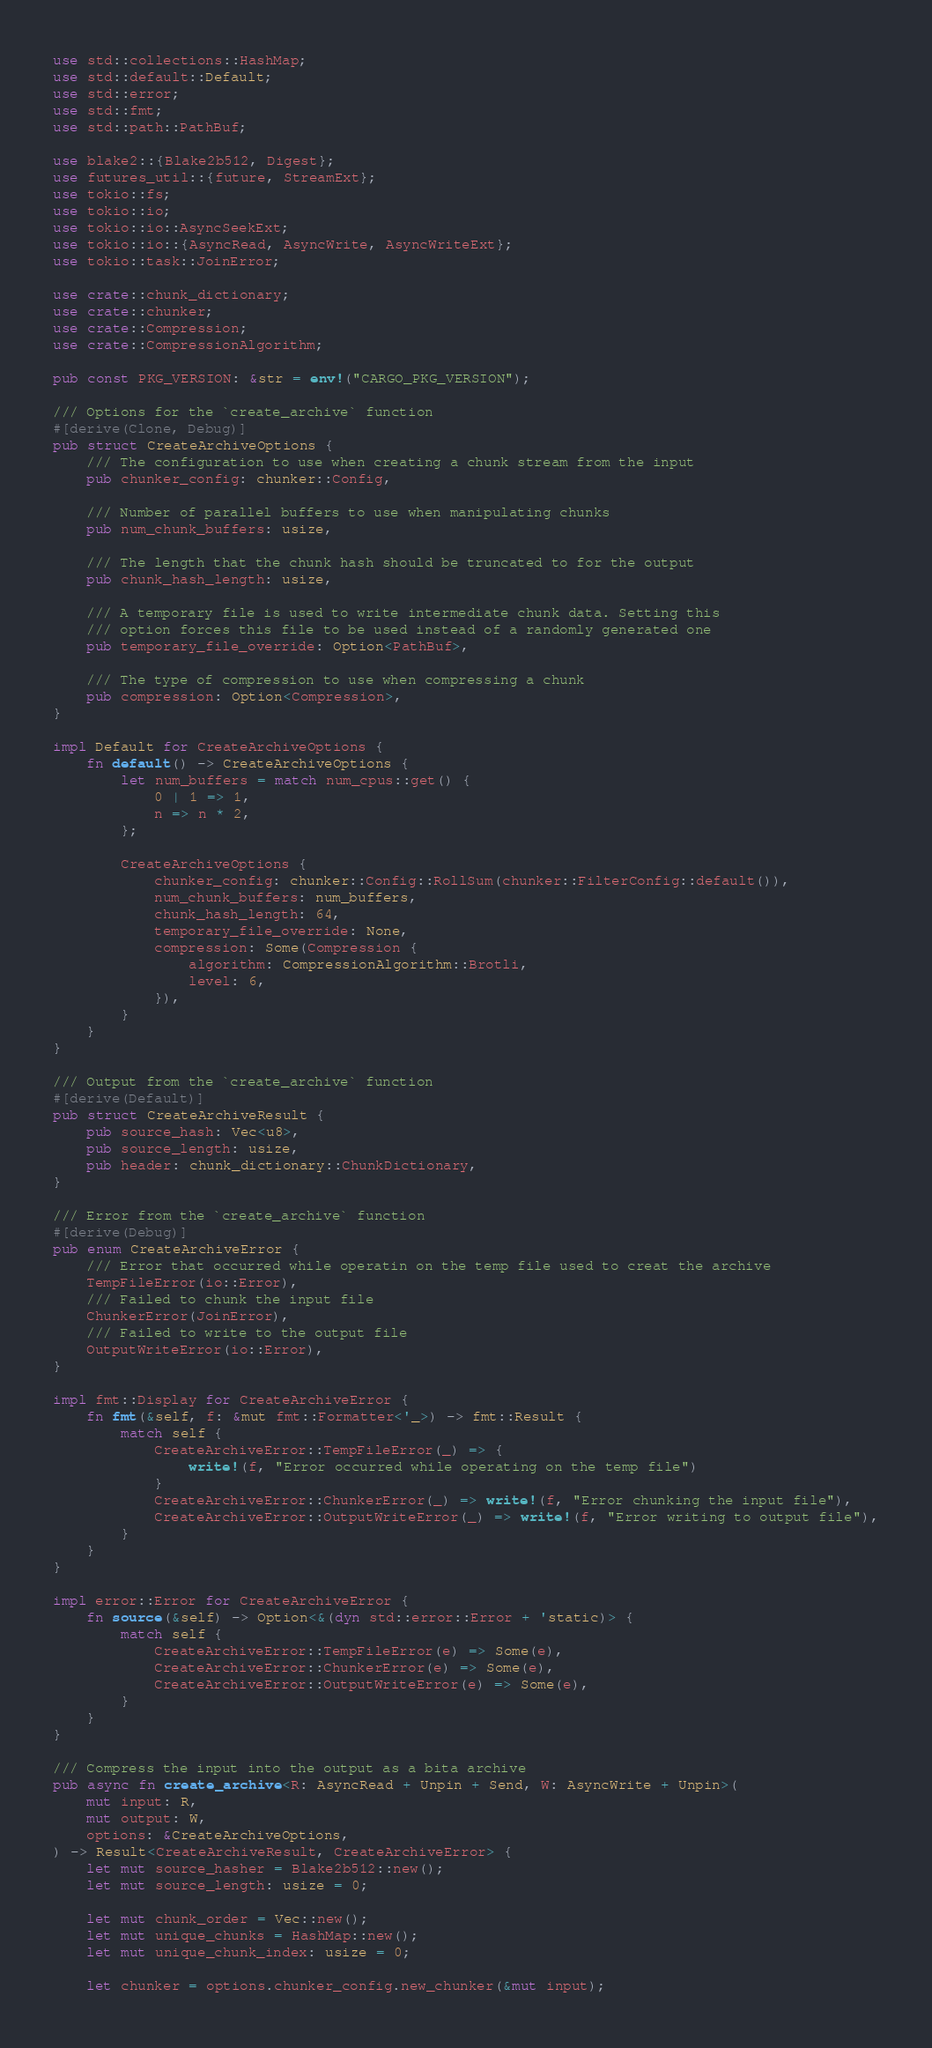Convert code to text. <code><loc_0><loc_0><loc_500><loc_500><_Rust_>use std::collections::HashMap;
use std::default::Default;
use std::error;
use std::fmt;
use std::path::PathBuf;

use blake2::{Blake2b512, Digest};
use futures_util::{future, StreamExt};
use tokio::fs;
use tokio::io;
use tokio::io::AsyncSeekExt;
use tokio::io::{AsyncRead, AsyncWrite, AsyncWriteExt};
use tokio::task::JoinError;

use crate::chunk_dictionary;
use crate::chunker;
use crate::Compression;
use crate::CompressionAlgorithm;

pub const PKG_VERSION: &str = env!("CARGO_PKG_VERSION");

/// Options for the `create_archive` function
#[derive(Clone, Debug)]
pub struct CreateArchiveOptions {
    /// The configuration to use when creating a chunk stream from the input
    pub chunker_config: chunker::Config,

    /// Number of parallel buffers to use when manipulating chunks
    pub num_chunk_buffers: usize,

    /// The length that the chunk hash should be truncated to for the output
    pub chunk_hash_length: usize,

    /// A temporary file is used to write intermediate chunk data. Setting this
    /// option forces this file to be used instead of a randomly generated one
    pub temporary_file_override: Option<PathBuf>,

    /// The type of compression to use when compressing a chunk
    pub compression: Option<Compression>,
}

impl Default for CreateArchiveOptions {
    fn default() -> CreateArchiveOptions {
        let num_buffers = match num_cpus::get() {
            0 | 1 => 1,
            n => n * 2,
        };

        CreateArchiveOptions {
            chunker_config: chunker::Config::RollSum(chunker::FilterConfig::default()),
            num_chunk_buffers: num_buffers,
            chunk_hash_length: 64,
            temporary_file_override: None,
            compression: Some(Compression {
                algorithm: CompressionAlgorithm::Brotli,
                level: 6,
            }),
        }
    }
}

/// Output from the `create_archive` function
#[derive(Default)]
pub struct CreateArchiveResult {
    pub source_hash: Vec<u8>,
    pub source_length: usize,
    pub header: chunk_dictionary::ChunkDictionary,
}

/// Error from the `create_archive` function
#[derive(Debug)]
pub enum CreateArchiveError {
    /// Error that occurred while operatin on the temp file used to creat the archive
    TempFileError(io::Error),
    /// Failed to chunk the input file
    ChunkerError(JoinError),
    /// Failed to write to the output file
    OutputWriteError(io::Error),
}

impl fmt::Display for CreateArchiveError {
    fn fmt(&self, f: &mut fmt::Formatter<'_>) -> fmt::Result {
        match self {
            CreateArchiveError::TempFileError(_) => {
                write!(f, "Error occurred while operating on the temp file")
            }
            CreateArchiveError::ChunkerError(_) => write!(f, "Error chunking the input file"),
            CreateArchiveError::OutputWriteError(_) => write!(f, "Error writing to output file"),
        }
    }
}

impl error::Error for CreateArchiveError {
    fn source(&self) -> Option<&(dyn std::error::Error + 'static)> {
        match self {
            CreateArchiveError::TempFileError(e) => Some(e),
            CreateArchiveError::ChunkerError(e) => Some(e),
            CreateArchiveError::OutputWriteError(e) => Some(e),
        }
    }
}

/// Compress the input into the output as a bita archive
pub async fn create_archive<R: AsyncRead + Unpin + Send, W: AsyncWrite + Unpin>(
    mut input: R,
    mut output: W,
    options: &CreateArchiveOptions,
) -> Result<CreateArchiveResult, CreateArchiveError> {
    let mut source_hasher = Blake2b512::new();
    let mut source_length: usize = 0;

    let mut chunk_order = Vec::new();
    let mut unique_chunks = HashMap::new();
    let mut unique_chunk_index: usize = 0;

    let chunker = options.chunker_config.new_chunker(&mut input);</code> 